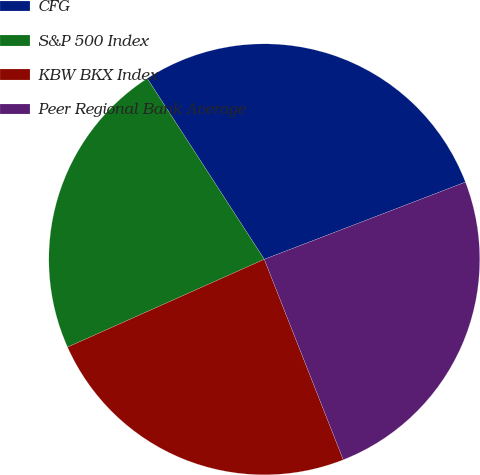Convert chart. <chart><loc_0><loc_0><loc_500><loc_500><pie_chart><fcel>CFG<fcel>S&P 500 Index<fcel>KBW BKX Index<fcel>Peer Regional Bank Average<nl><fcel>28.31%<fcel>22.54%<fcel>24.29%<fcel>24.86%<nl></chart> 